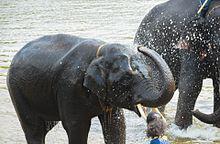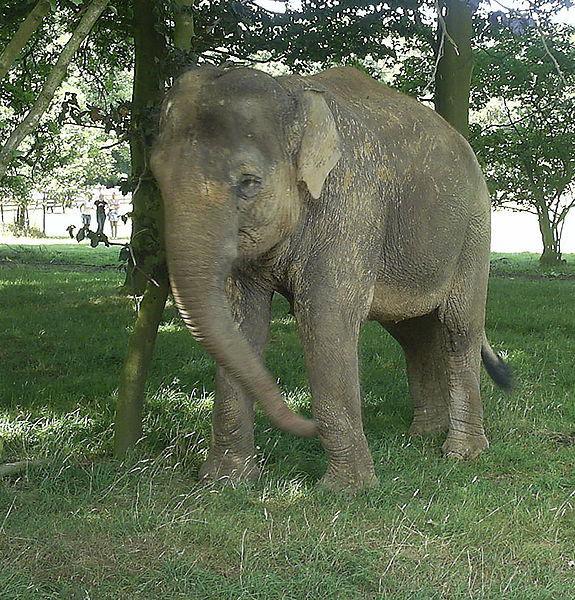The first image is the image on the left, the second image is the image on the right. Considering the images on both sides, is "There are more animals in the image on the right." valid? Answer yes or no. No. 